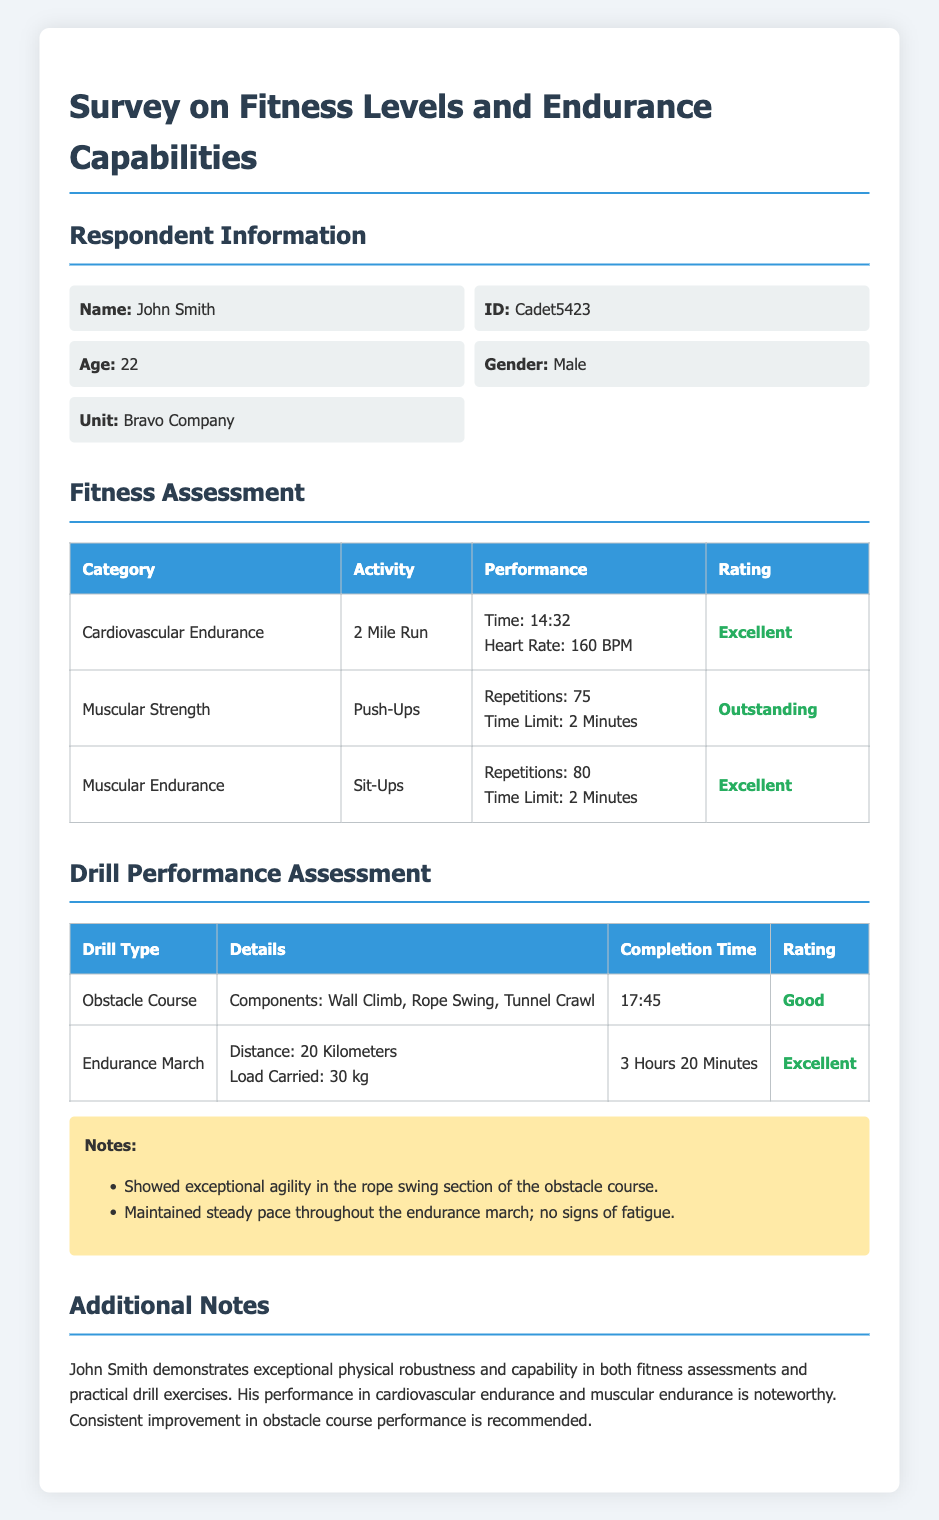What is the name of the respondent? The respondent's name is provided under the Respondent Information section.
Answer: John Smith What is the ID of the respondent? The ID can be found in the Respondent Information section.
Answer: Cadet5423 How old is the respondent? The age of the respondent is listed in the Respondent Information section.
Answer: 22 What performance rating did John Smith receive for the 2 Mile Run? The rating is included in the Fitness Assessment table for the 2 Mile Run activity.
Answer: Excellent How long did it take to complete the Endurance March? The completion time for the Endurance March is specified in the Drill Performance Assessment table.
Answer: 3 Hours 20 Minutes What components are included in the Obstacle Course? The details of the obstacle course can be found in the Drill Performance Assessment section.
Answer: Wall Climb, Rope Swing, Tunnel Crawl What additional notes were provided about the respondent? The Additional Notes section summarizes insights about the respondent's performance and skills.
Answer: Consistent improvement in obstacle course performance is recommended What is the maximum number of push-ups completed? The performance for the Push-Ups activity is recorded in the Fitness Assessment table.
Answer: 75 How was John Smith's agility described during the obstacle course assessment? This information is noted in the notes section related to the Drill Performance Assessment.
Answer: Exceptional agility 